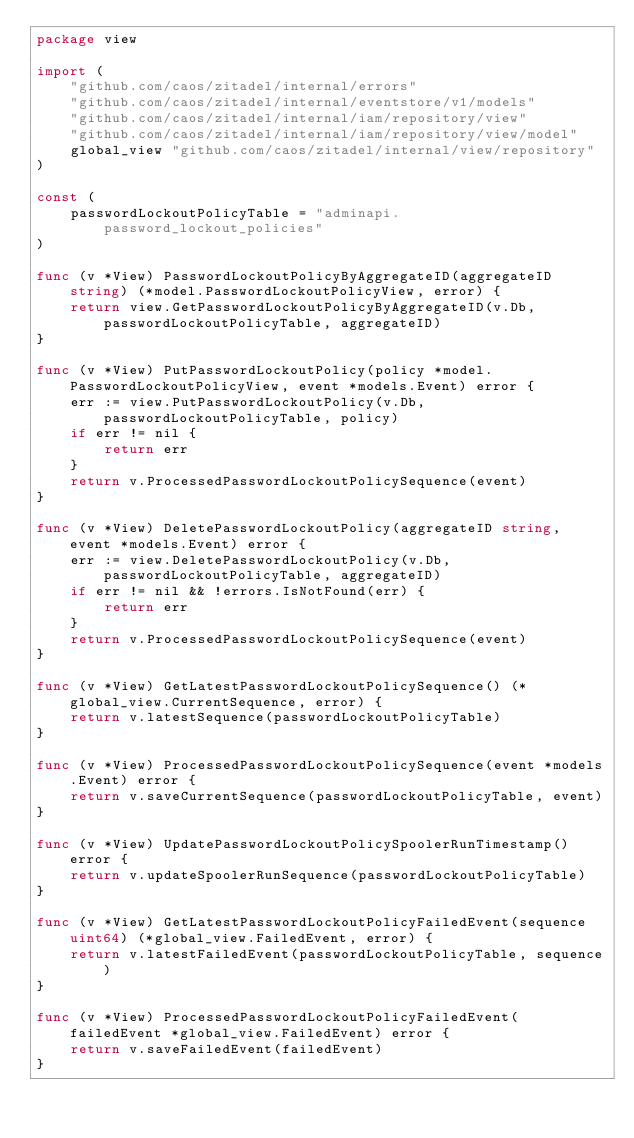<code> <loc_0><loc_0><loc_500><loc_500><_Go_>package view

import (
	"github.com/caos/zitadel/internal/errors"
	"github.com/caos/zitadel/internal/eventstore/v1/models"
	"github.com/caos/zitadel/internal/iam/repository/view"
	"github.com/caos/zitadel/internal/iam/repository/view/model"
	global_view "github.com/caos/zitadel/internal/view/repository"
)

const (
	passwordLockoutPolicyTable = "adminapi.password_lockout_policies"
)

func (v *View) PasswordLockoutPolicyByAggregateID(aggregateID string) (*model.PasswordLockoutPolicyView, error) {
	return view.GetPasswordLockoutPolicyByAggregateID(v.Db, passwordLockoutPolicyTable, aggregateID)
}

func (v *View) PutPasswordLockoutPolicy(policy *model.PasswordLockoutPolicyView, event *models.Event) error {
	err := view.PutPasswordLockoutPolicy(v.Db, passwordLockoutPolicyTable, policy)
	if err != nil {
		return err
	}
	return v.ProcessedPasswordLockoutPolicySequence(event)
}

func (v *View) DeletePasswordLockoutPolicy(aggregateID string, event *models.Event) error {
	err := view.DeletePasswordLockoutPolicy(v.Db, passwordLockoutPolicyTable, aggregateID)
	if err != nil && !errors.IsNotFound(err) {
		return err
	}
	return v.ProcessedPasswordLockoutPolicySequence(event)
}

func (v *View) GetLatestPasswordLockoutPolicySequence() (*global_view.CurrentSequence, error) {
	return v.latestSequence(passwordLockoutPolicyTable)
}

func (v *View) ProcessedPasswordLockoutPolicySequence(event *models.Event) error {
	return v.saveCurrentSequence(passwordLockoutPolicyTable, event)
}

func (v *View) UpdatePasswordLockoutPolicySpoolerRunTimestamp() error {
	return v.updateSpoolerRunSequence(passwordLockoutPolicyTable)
}

func (v *View) GetLatestPasswordLockoutPolicyFailedEvent(sequence uint64) (*global_view.FailedEvent, error) {
	return v.latestFailedEvent(passwordLockoutPolicyTable, sequence)
}

func (v *View) ProcessedPasswordLockoutPolicyFailedEvent(failedEvent *global_view.FailedEvent) error {
	return v.saveFailedEvent(failedEvent)
}
</code> 